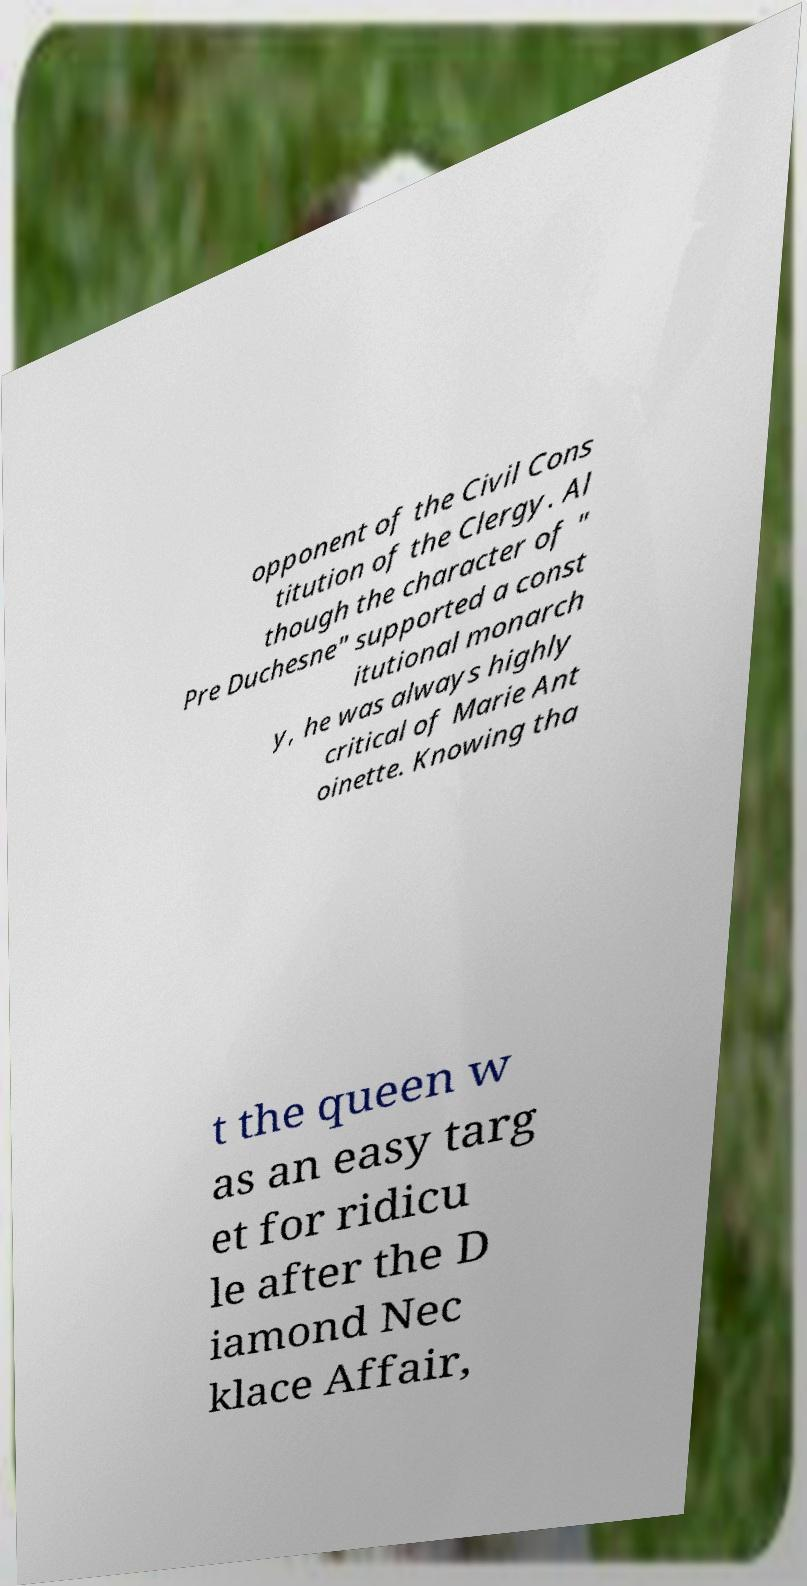What messages or text are displayed in this image? I need them in a readable, typed format. opponent of the Civil Cons titution of the Clergy. Al though the character of " Pre Duchesne" supported a const itutional monarch y, he was always highly critical of Marie Ant oinette. Knowing tha t the queen w as an easy targ et for ridicu le after the D iamond Nec klace Affair, 